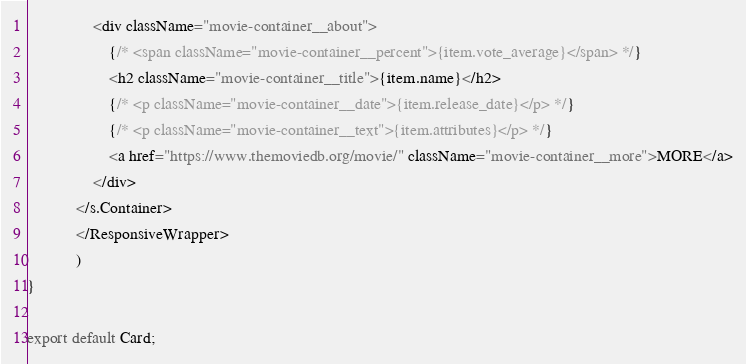<code> <loc_0><loc_0><loc_500><loc_500><_JavaScript_>                <div className="movie-container__about">
                    {/* <span className="movie-container__percent">{item.vote_average}</span> */}
                    <h2 className="movie-container__title">{item.name}</h2>
                    {/* <p className="movie-container__date">{item.release_date}</p> */}
                    {/* <p className="movie-container__text">{item.attributes}</p> */}
                    <a href="https://www.themoviedb.org/movie/" className="movie-container__more">MORE</a>
                </div>
            </s.Container>
            </ResponsiveWrapper>
            )
}

export default Card;</code> 